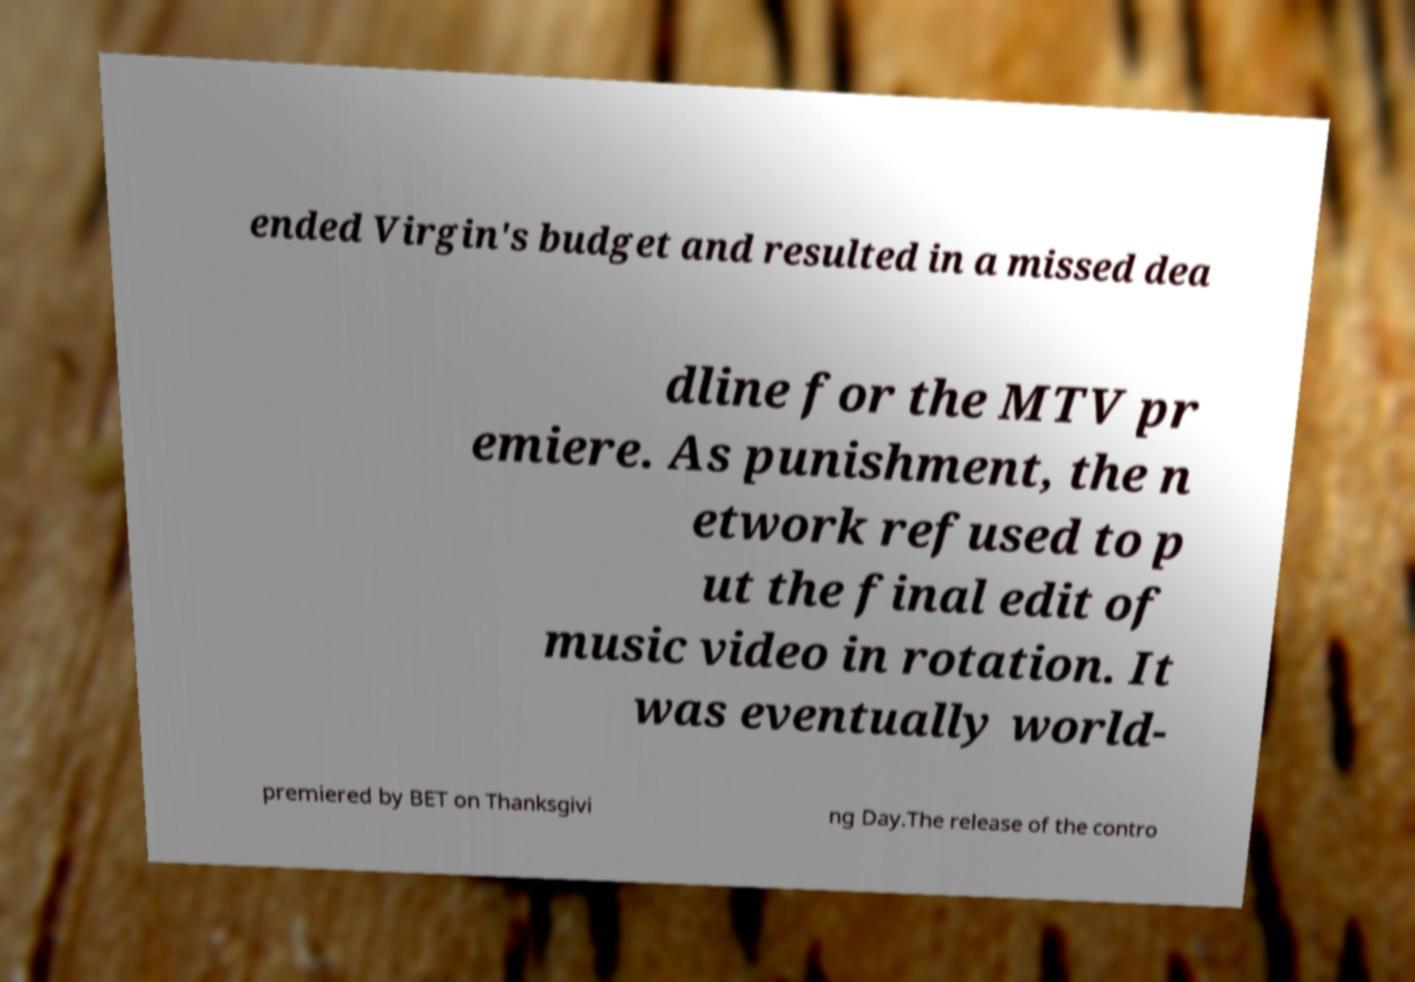Please read and relay the text visible in this image. What does it say? ended Virgin's budget and resulted in a missed dea dline for the MTV pr emiere. As punishment, the n etwork refused to p ut the final edit of music video in rotation. It was eventually world- premiered by BET on Thanksgivi ng Day.The release of the contro 